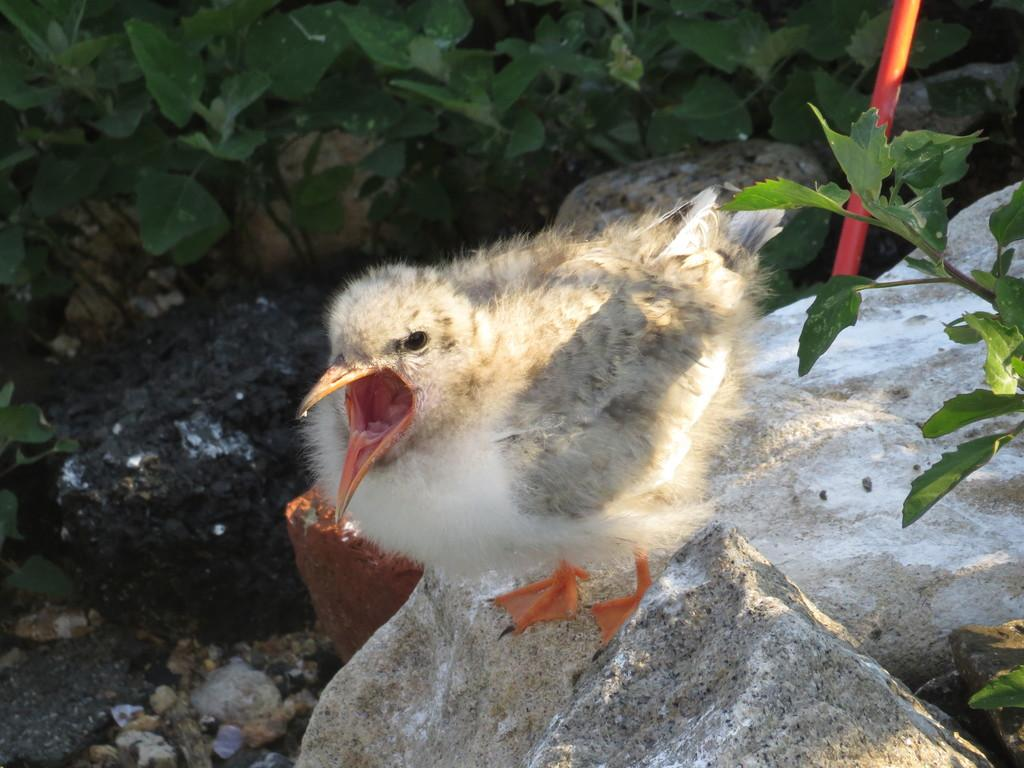What type of animal is in the image? There is a bird in the image. Can you describe the bird's appearance? The bird is white and grey in color. Where is the bird located in the image? The bird is on a stone. What type of vegetation is visible in the image? There are green leaves visible in the image. What type of education does the bird have, as seen in the image? There is no indication in the image that the bird has received any education. 